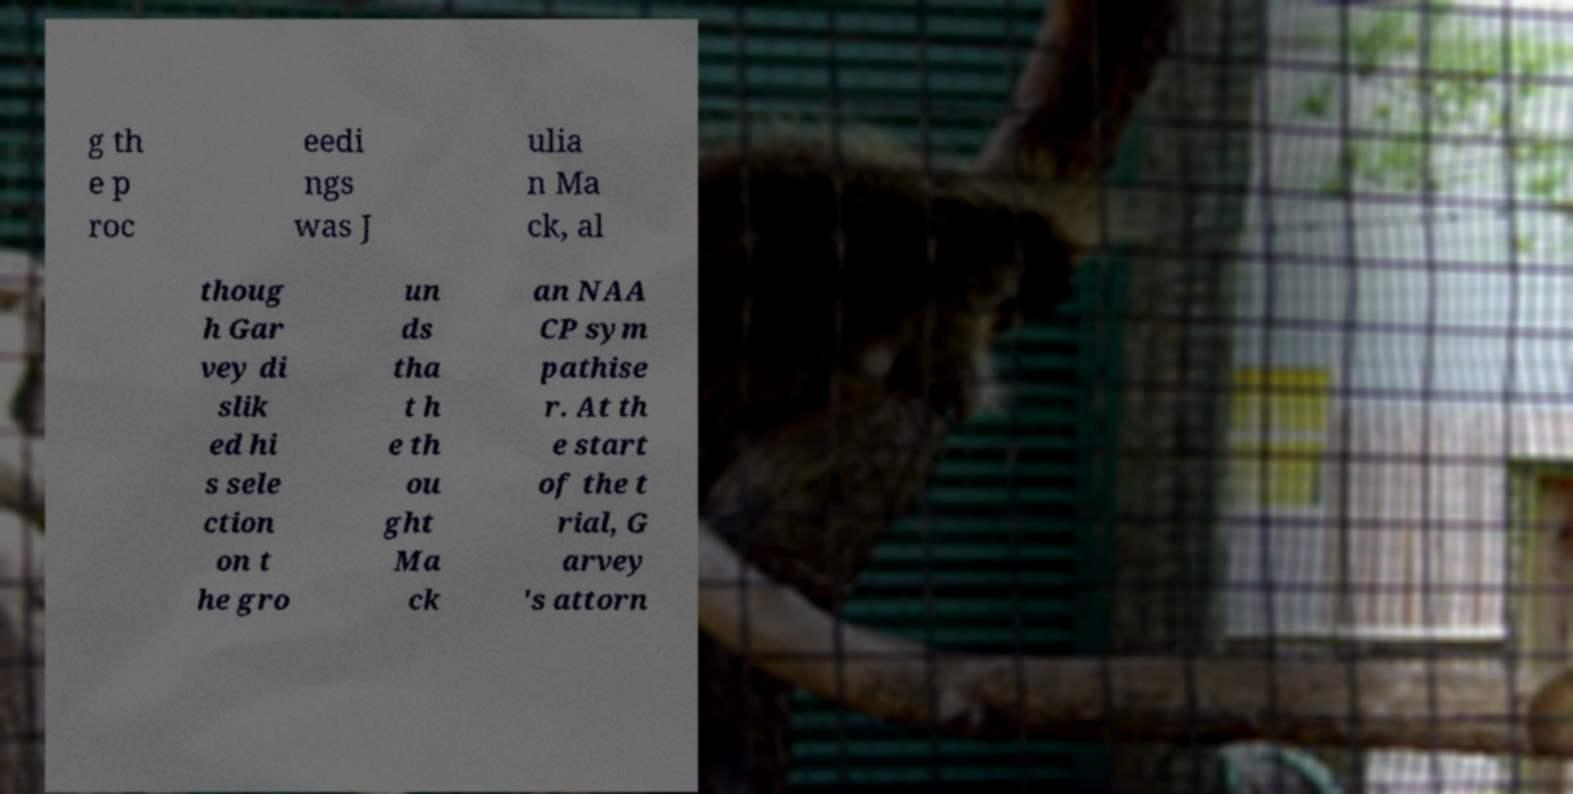Could you assist in decoding the text presented in this image and type it out clearly? g th e p roc eedi ngs was J ulia n Ma ck, al thoug h Gar vey di slik ed hi s sele ction on t he gro un ds tha t h e th ou ght Ma ck an NAA CP sym pathise r. At th e start of the t rial, G arvey 's attorn 